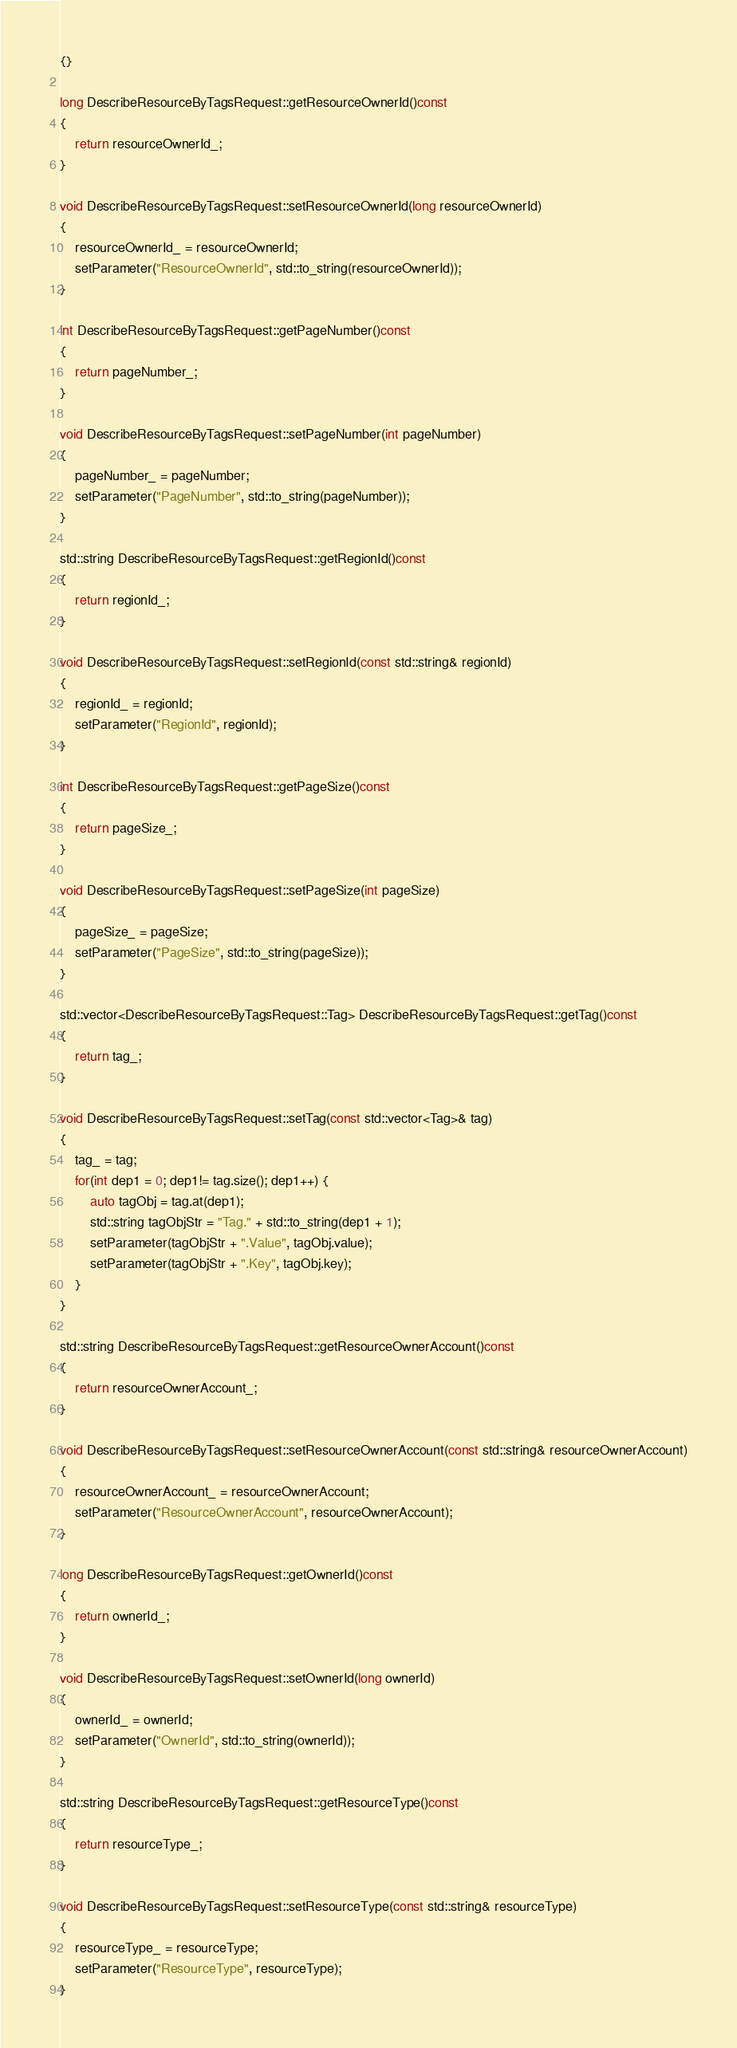<code> <loc_0><loc_0><loc_500><loc_500><_C++_>{}

long DescribeResourceByTagsRequest::getResourceOwnerId()const
{
	return resourceOwnerId_;
}

void DescribeResourceByTagsRequest::setResourceOwnerId(long resourceOwnerId)
{
	resourceOwnerId_ = resourceOwnerId;
	setParameter("ResourceOwnerId", std::to_string(resourceOwnerId));
}

int DescribeResourceByTagsRequest::getPageNumber()const
{
	return pageNumber_;
}

void DescribeResourceByTagsRequest::setPageNumber(int pageNumber)
{
	pageNumber_ = pageNumber;
	setParameter("PageNumber", std::to_string(pageNumber));
}

std::string DescribeResourceByTagsRequest::getRegionId()const
{
	return regionId_;
}

void DescribeResourceByTagsRequest::setRegionId(const std::string& regionId)
{
	regionId_ = regionId;
	setParameter("RegionId", regionId);
}

int DescribeResourceByTagsRequest::getPageSize()const
{
	return pageSize_;
}

void DescribeResourceByTagsRequest::setPageSize(int pageSize)
{
	pageSize_ = pageSize;
	setParameter("PageSize", std::to_string(pageSize));
}

std::vector<DescribeResourceByTagsRequest::Tag> DescribeResourceByTagsRequest::getTag()const
{
	return tag_;
}

void DescribeResourceByTagsRequest::setTag(const std::vector<Tag>& tag)
{
	tag_ = tag;
	for(int dep1 = 0; dep1!= tag.size(); dep1++) {
		auto tagObj = tag.at(dep1);
		std::string tagObjStr = "Tag." + std::to_string(dep1 + 1);
		setParameter(tagObjStr + ".Value", tagObj.value);
		setParameter(tagObjStr + ".Key", tagObj.key);
	}
}

std::string DescribeResourceByTagsRequest::getResourceOwnerAccount()const
{
	return resourceOwnerAccount_;
}

void DescribeResourceByTagsRequest::setResourceOwnerAccount(const std::string& resourceOwnerAccount)
{
	resourceOwnerAccount_ = resourceOwnerAccount;
	setParameter("ResourceOwnerAccount", resourceOwnerAccount);
}

long DescribeResourceByTagsRequest::getOwnerId()const
{
	return ownerId_;
}

void DescribeResourceByTagsRequest::setOwnerId(long ownerId)
{
	ownerId_ = ownerId;
	setParameter("OwnerId", std::to_string(ownerId));
}

std::string DescribeResourceByTagsRequest::getResourceType()const
{
	return resourceType_;
}

void DescribeResourceByTagsRequest::setResourceType(const std::string& resourceType)
{
	resourceType_ = resourceType;
	setParameter("ResourceType", resourceType);
}

</code> 